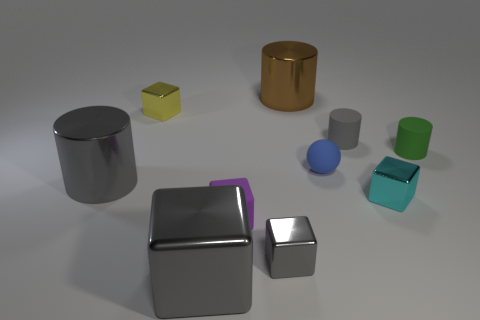Is the material of the tiny object that is left of the tiny purple object the same as the large gray thing to the left of the yellow shiny thing?
Keep it short and to the point. Yes. What number of big metallic cylinders are on the right side of the big cube and on the left side of the small yellow cube?
Provide a succinct answer. 0. Are there any small blue rubber things of the same shape as the tiny yellow thing?
Offer a terse response. No. There is a blue matte object that is the same size as the cyan metal cube; what shape is it?
Keep it short and to the point. Sphere. Is the number of matte balls left of the brown cylinder the same as the number of large gray shiny objects that are in front of the small yellow object?
Your answer should be very brief. No. There is a matte cylinder on the right side of the small cylinder that is behind the small green matte cylinder; what size is it?
Your answer should be compact. Small. Are there any purple things that have the same size as the sphere?
Your response must be concise. Yes. What is the color of the ball that is made of the same material as the small purple cube?
Make the answer very short. Blue. Is the number of small gray metallic blocks less than the number of big purple metal objects?
Your answer should be very brief. No. What material is the large object that is behind the small cyan metal cube and in front of the yellow metal object?
Give a very brief answer. Metal. 